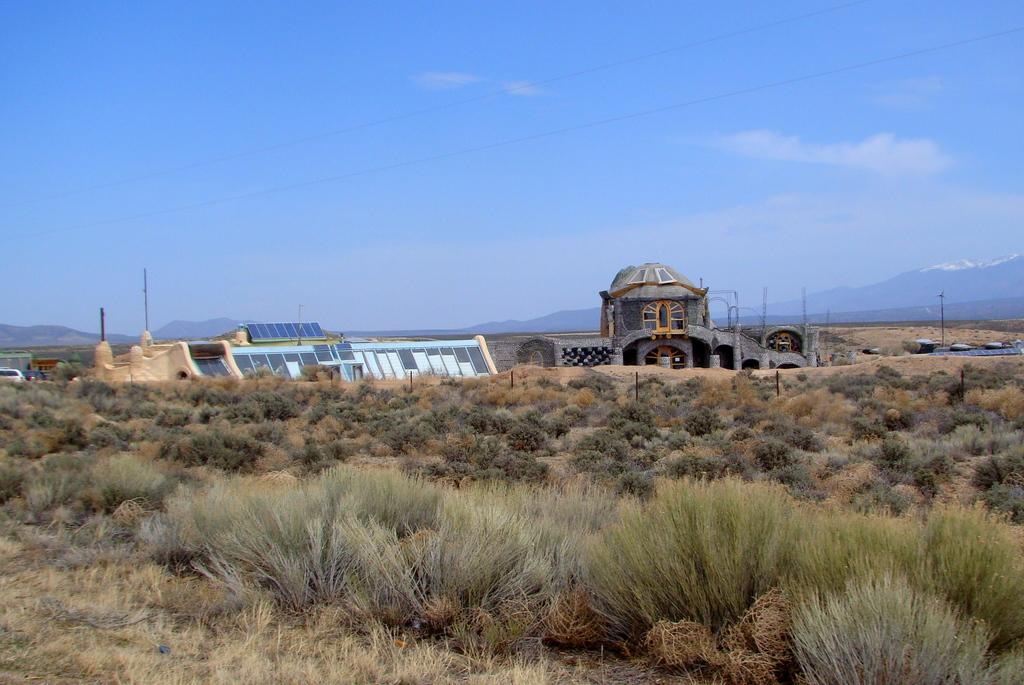What type of structures can be seen in the image? There are houses in the image. What natural feature surrounds the houses in the image? The houses are surrounded by mountains. What type of vegetation is present in the image? There are bushes in the image. What color is the sky in the image? The sky is blue in the image. What type of animal can be seen climbing the top of the mountain in the image? There are no animals visible in the image, and no animals are climbing the top of the mountain. 